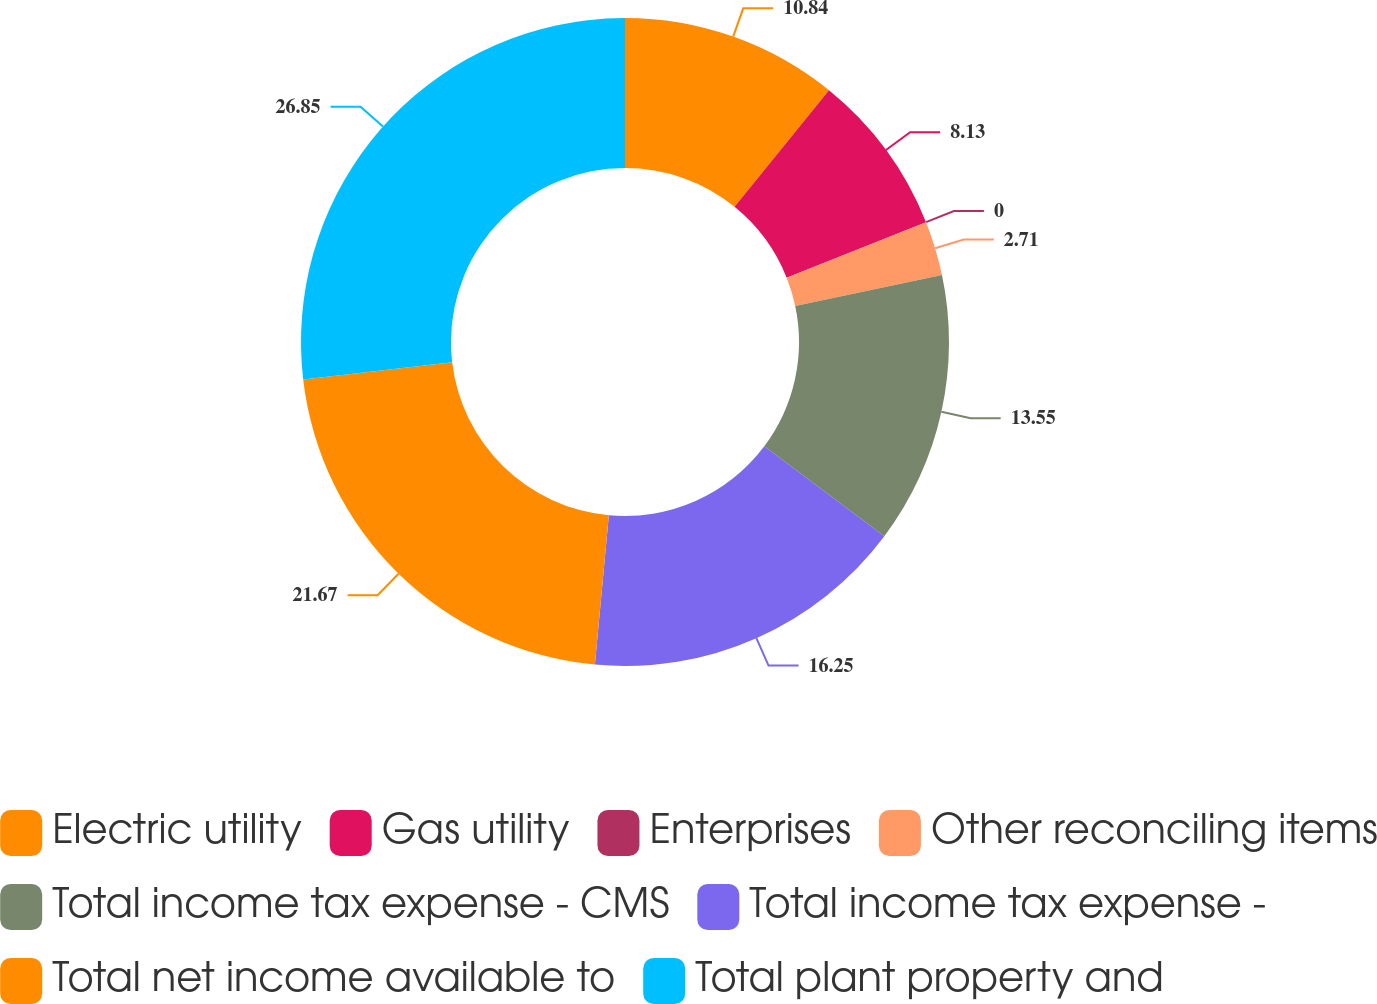<chart> <loc_0><loc_0><loc_500><loc_500><pie_chart><fcel>Electric utility<fcel>Gas utility<fcel>Enterprises<fcel>Other reconciling items<fcel>Total income tax expense - CMS<fcel>Total income tax expense -<fcel>Total net income available to<fcel>Total plant property and<nl><fcel>10.84%<fcel>8.13%<fcel>0.0%<fcel>2.71%<fcel>13.55%<fcel>16.25%<fcel>21.67%<fcel>26.85%<nl></chart> 